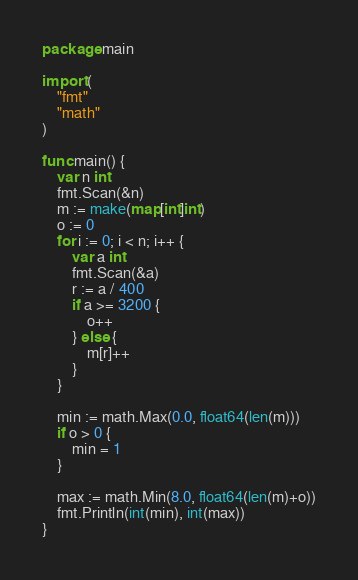Convert code to text. <code><loc_0><loc_0><loc_500><loc_500><_Go_>package main

import (
	"fmt"
	"math"
)

func main() {
	var n int
	fmt.Scan(&n)
	m := make(map[int]int)
	o := 0
	for i := 0; i < n; i++ {
		var a int
		fmt.Scan(&a)
		r := a / 400
		if a >= 3200 {
			o++
		} else {
			m[r]++
		}
	}

	min := math.Max(0.0, float64(len(m)))
	if o > 0 {
		min = 1
	}

	max := math.Min(8.0, float64(len(m)+o))
	fmt.Println(int(min), int(max))
}
</code> 